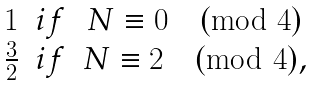<formula> <loc_0><loc_0><loc_500><loc_500>\begin{matrix} 1 & i f & N \equiv 0 \pmod { 4 } \\ \frac { 3 } { 2 } & i f & N \equiv 2 \pmod { 4 } , \end{matrix}</formula> 